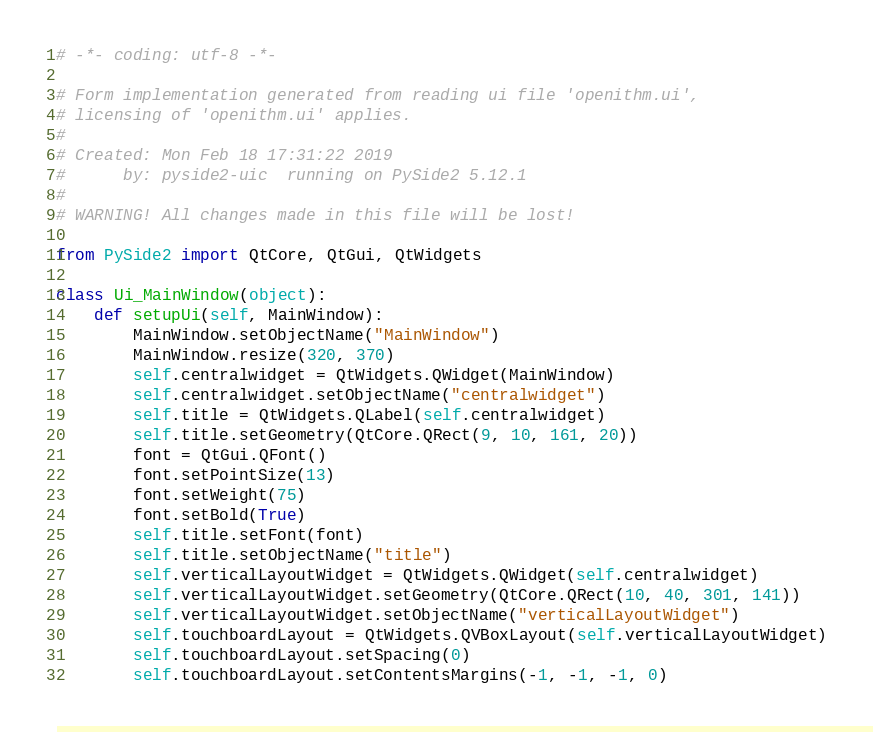Convert code to text. <code><loc_0><loc_0><loc_500><loc_500><_Python_># -*- coding: utf-8 -*-

# Form implementation generated from reading ui file 'openithm.ui',
# licensing of 'openithm.ui' applies.
#
# Created: Mon Feb 18 17:31:22 2019
#      by: pyside2-uic  running on PySide2 5.12.1
#
# WARNING! All changes made in this file will be lost!

from PySide2 import QtCore, QtGui, QtWidgets

class Ui_MainWindow(object):
    def setupUi(self, MainWindow):
        MainWindow.setObjectName("MainWindow")
        MainWindow.resize(320, 370)
        self.centralwidget = QtWidgets.QWidget(MainWindow)
        self.centralwidget.setObjectName("centralwidget")
        self.title = QtWidgets.QLabel(self.centralwidget)
        self.title.setGeometry(QtCore.QRect(9, 10, 161, 20))
        font = QtGui.QFont()
        font.setPointSize(13)
        font.setWeight(75)
        font.setBold(True)
        self.title.setFont(font)
        self.title.setObjectName("title")
        self.verticalLayoutWidget = QtWidgets.QWidget(self.centralwidget)
        self.verticalLayoutWidget.setGeometry(QtCore.QRect(10, 40, 301, 141))
        self.verticalLayoutWidget.setObjectName("verticalLayoutWidget")
        self.touchboardLayout = QtWidgets.QVBoxLayout(self.verticalLayoutWidget)
        self.touchboardLayout.setSpacing(0)
        self.touchboardLayout.setContentsMargins(-1, -1, -1, 0)</code> 